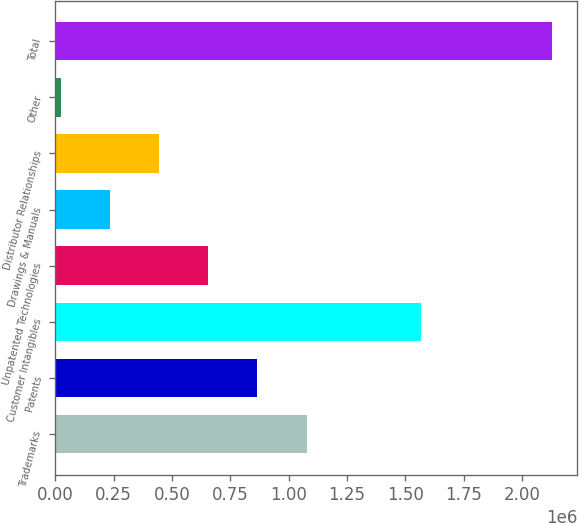<chart> <loc_0><loc_0><loc_500><loc_500><bar_chart><fcel>Trademarks<fcel>Patents<fcel>Customer Intangibles<fcel>Unpatented Technologies<fcel>Drawings & Manuals<fcel>Distributor Relationships<fcel>Other<fcel>Total<nl><fcel>1.07658e+06<fcel>866047<fcel>1.56705e+06<fcel>655516<fcel>234454<fcel>444985<fcel>23923<fcel>2.12923e+06<nl></chart> 